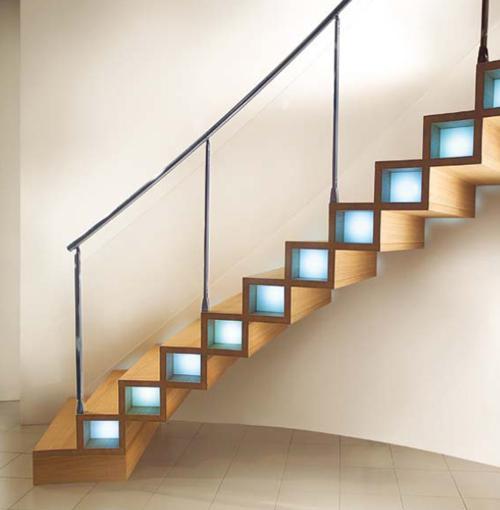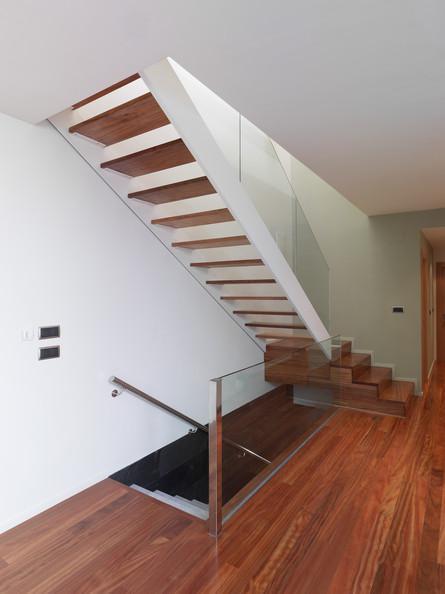The first image is the image on the left, the second image is the image on the right. Assess this claim about the two images: "The vertical posts on the stairway are all wood.". Correct or not? Answer yes or no. No. The first image is the image on the left, the second image is the image on the right. For the images displayed, is the sentence "One image shows a side view of stairs that ascend to the right and have a handrail with vertical supports spaced apart instead of close together." factually correct? Answer yes or no. Yes. 